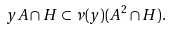Convert formula to latex. <formula><loc_0><loc_0><loc_500><loc_500>y A \cap H \subset \nu ( y ) ( A ^ { 2 } \cap H ) .</formula> 